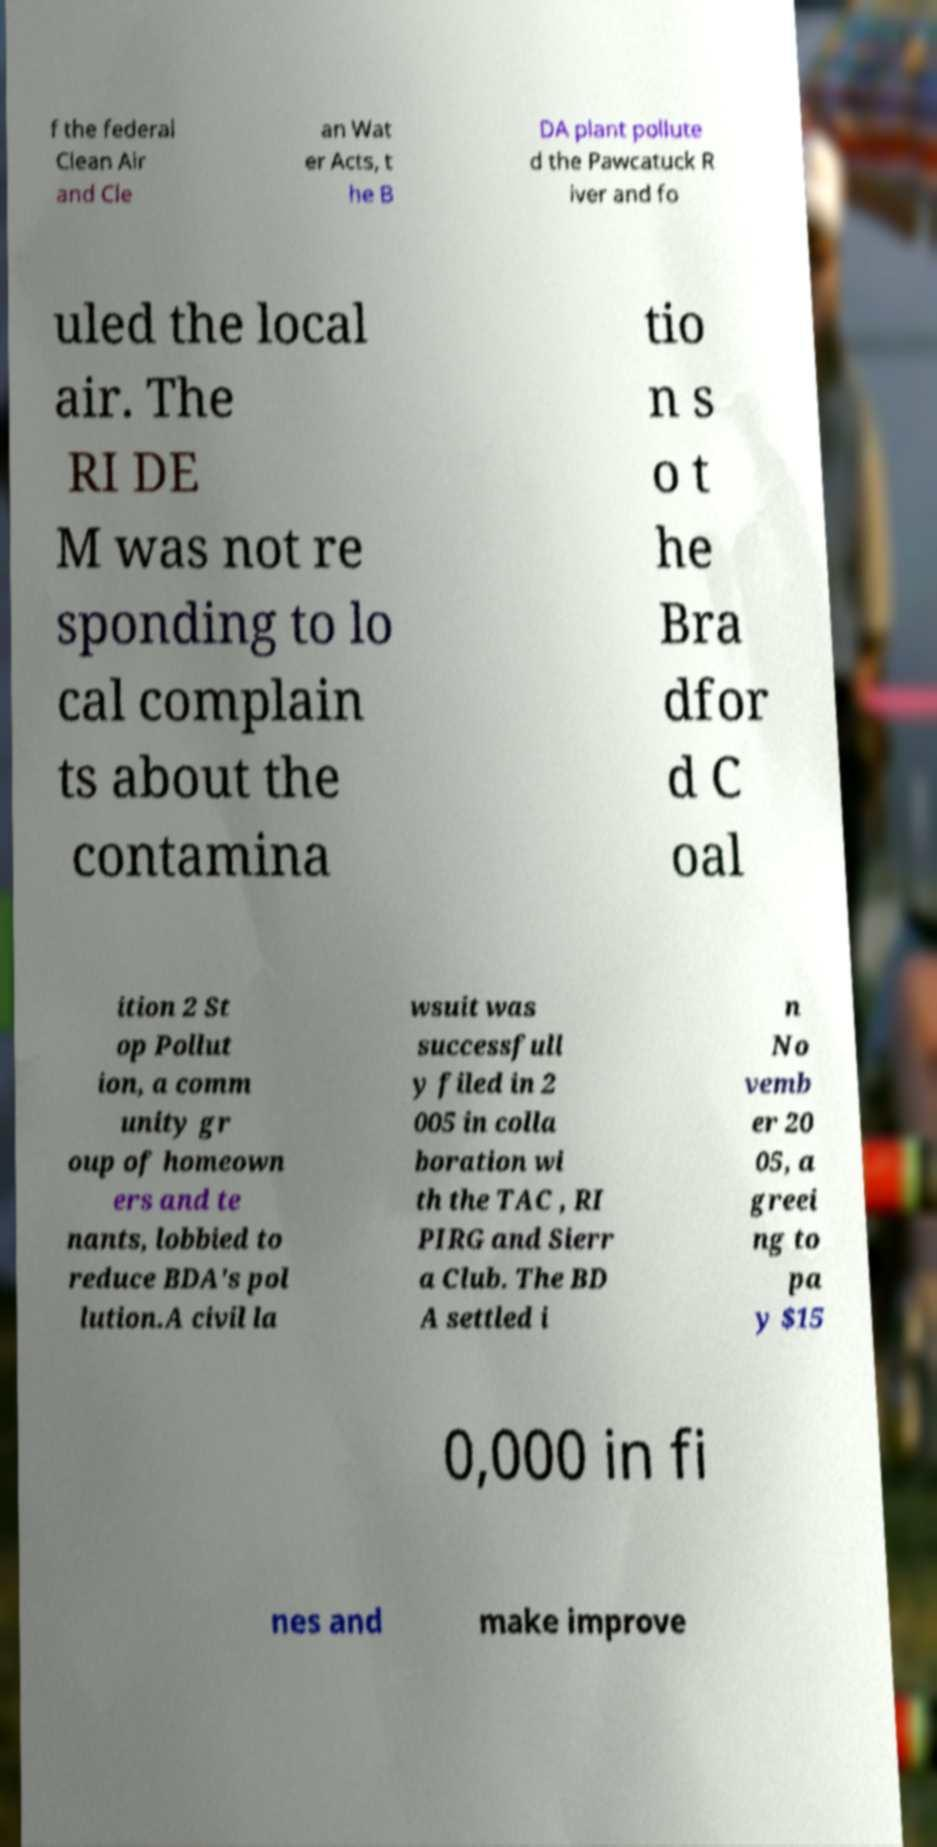Could you assist in decoding the text presented in this image and type it out clearly? f the federal Clean Air and Cle an Wat er Acts, t he B DA plant pollute d the Pawcatuck R iver and fo uled the local air. The RI DE M was not re sponding to lo cal complain ts about the contamina tio n s o t he Bra dfor d C oal ition 2 St op Pollut ion, a comm unity gr oup of homeown ers and te nants, lobbied to reduce BDA's pol lution.A civil la wsuit was successfull y filed in 2 005 in colla boration wi th the TAC , RI PIRG and Sierr a Club. The BD A settled i n No vemb er 20 05, a greei ng to pa y $15 0,000 in fi nes and make improve 